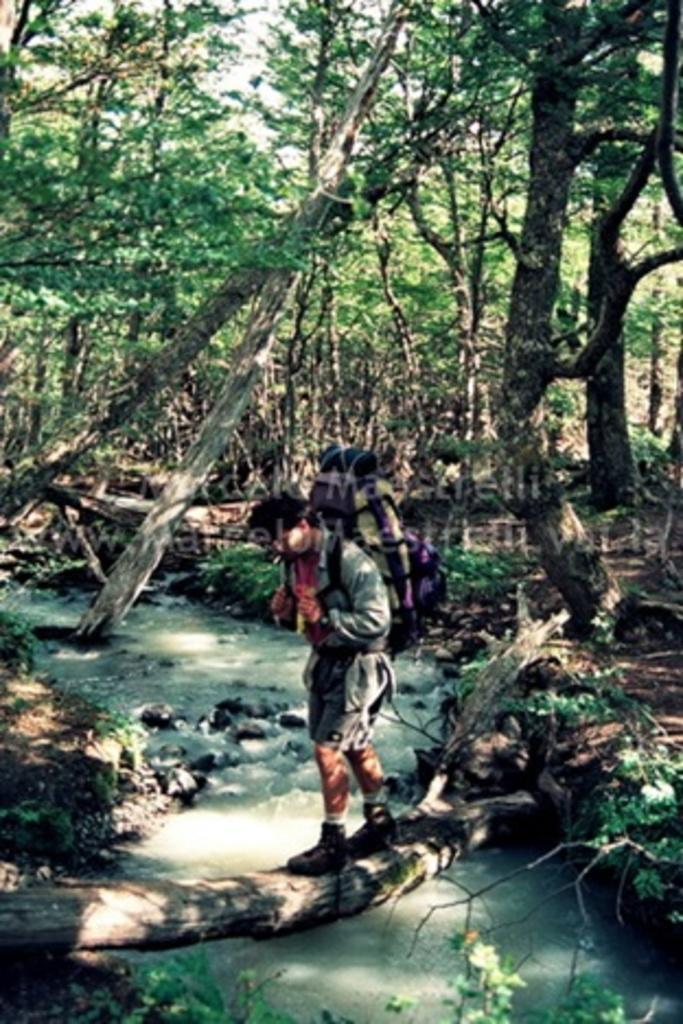In one or two sentences, can you explain what this image depicts? In this image in the center there is one person who is walking, and at the bottom there is one lake. In the background there are some trees and some plants. 